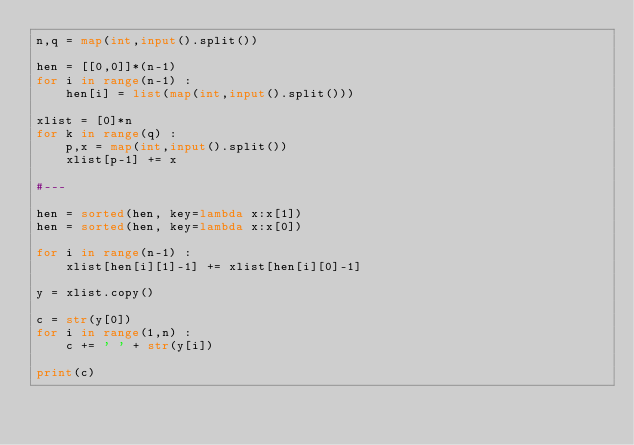<code> <loc_0><loc_0><loc_500><loc_500><_Python_>n,q = map(int,input().split())

hen = [[0,0]]*(n-1)
for i in range(n-1) :
    hen[i] = list(map(int,input().split()))

xlist = [0]*n
for k in range(q) :
    p,x = map(int,input().split())
    xlist[p-1] += x

#---

hen = sorted(hen, key=lambda x:x[1])
hen = sorted(hen, key=lambda x:x[0])

for i in range(n-1) :
    xlist[hen[i][1]-1] += xlist[hen[i][0]-1]

y = xlist.copy()

c = str(y[0])
for i in range(1,n) :
    c += ' ' + str(y[i])

print(c)</code> 